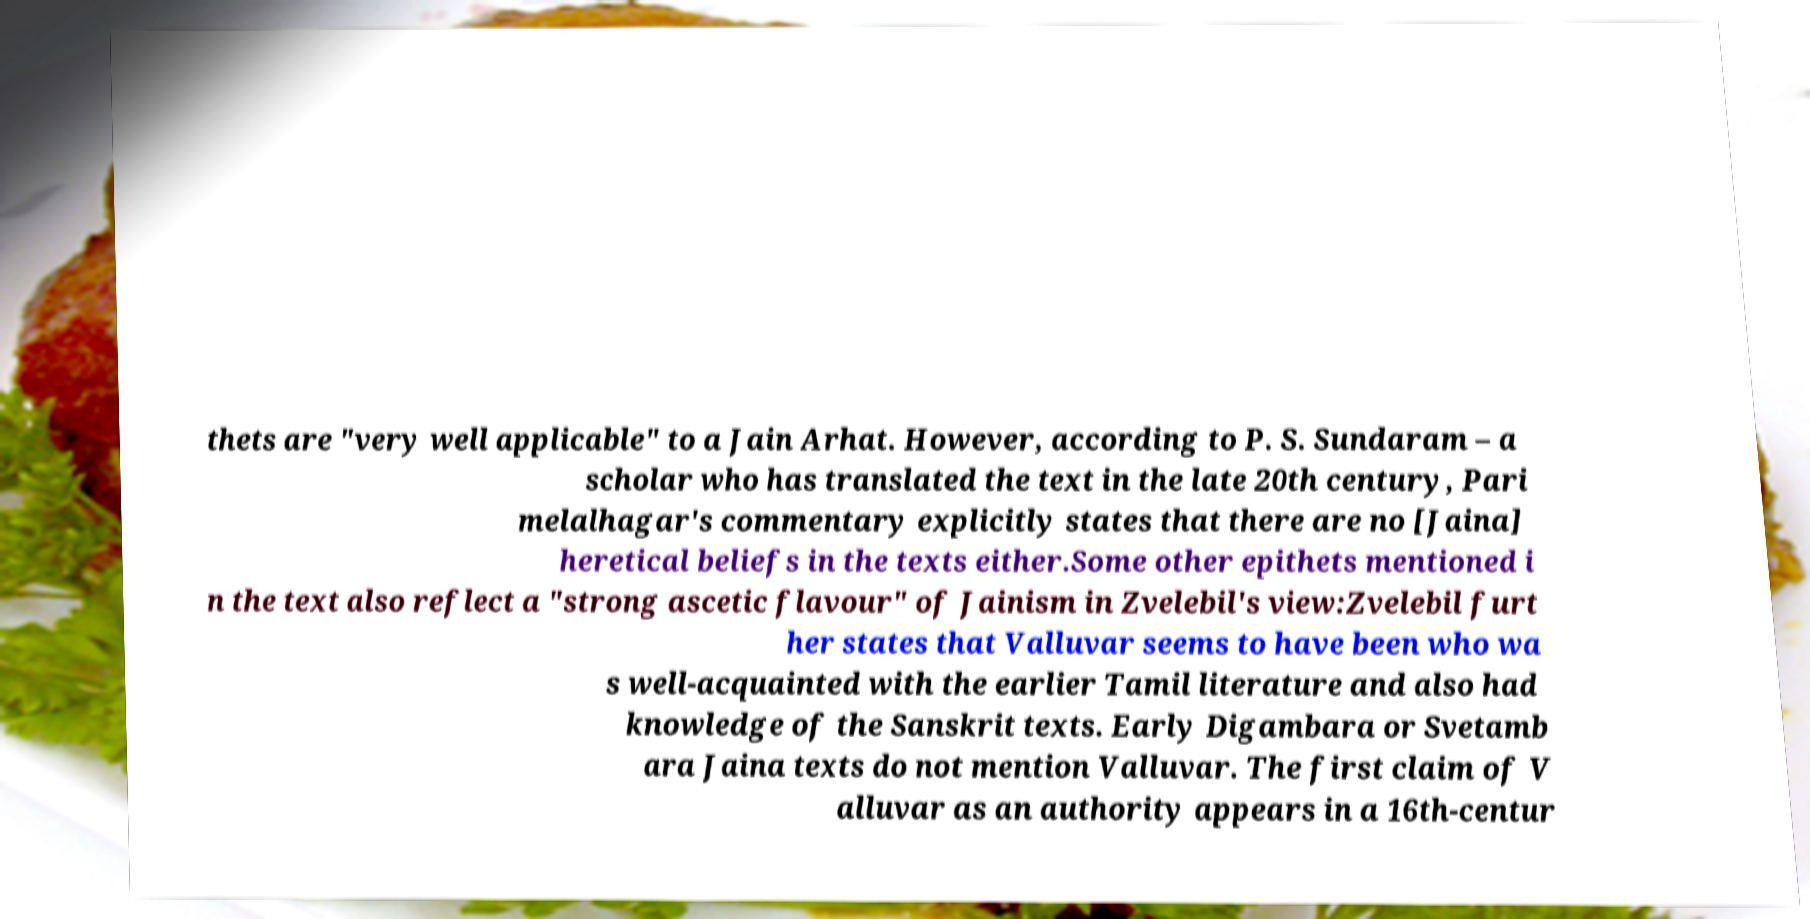For documentation purposes, I need the text within this image transcribed. Could you provide that? thets are "very well applicable" to a Jain Arhat. However, according to P. S. Sundaram – a scholar who has translated the text in the late 20th century, Pari melalhagar's commentary explicitly states that there are no [Jaina] heretical beliefs in the texts either.Some other epithets mentioned i n the text also reflect a "strong ascetic flavour" of Jainism in Zvelebil's view:Zvelebil furt her states that Valluvar seems to have been who wa s well-acquainted with the earlier Tamil literature and also had knowledge of the Sanskrit texts. Early Digambara or Svetamb ara Jaina texts do not mention Valluvar. The first claim of V alluvar as an authority appears in a 16th-centur 